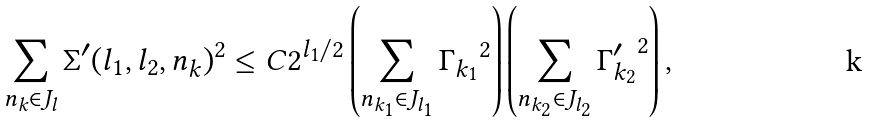<formula> <loc_0><loc_0><loc_500><loc_500>\sum _ { n _ { k } \in J _ { l } } \Sigma ^ { \prime } ( l _ { 1 } , l _ { 2 } , n _ { k } ) ^ { 2 } \leq C 2 ^ { l _ { 1 } / 2 } \left ( \sum _ { n _ { k _ { 1 } } \in J _ { l _ { 1 } } } { \Gamma _ { k _ { 1 } } } ^ { 2 } \right ) \left ( \sum _ { n _ { k _ { 2 } } \in J _ { l _ { 2 } } } { \Gamma ^ { \prime } _ { k _ { 2 } } } ^ { 2 } \right ) ,</formula> 